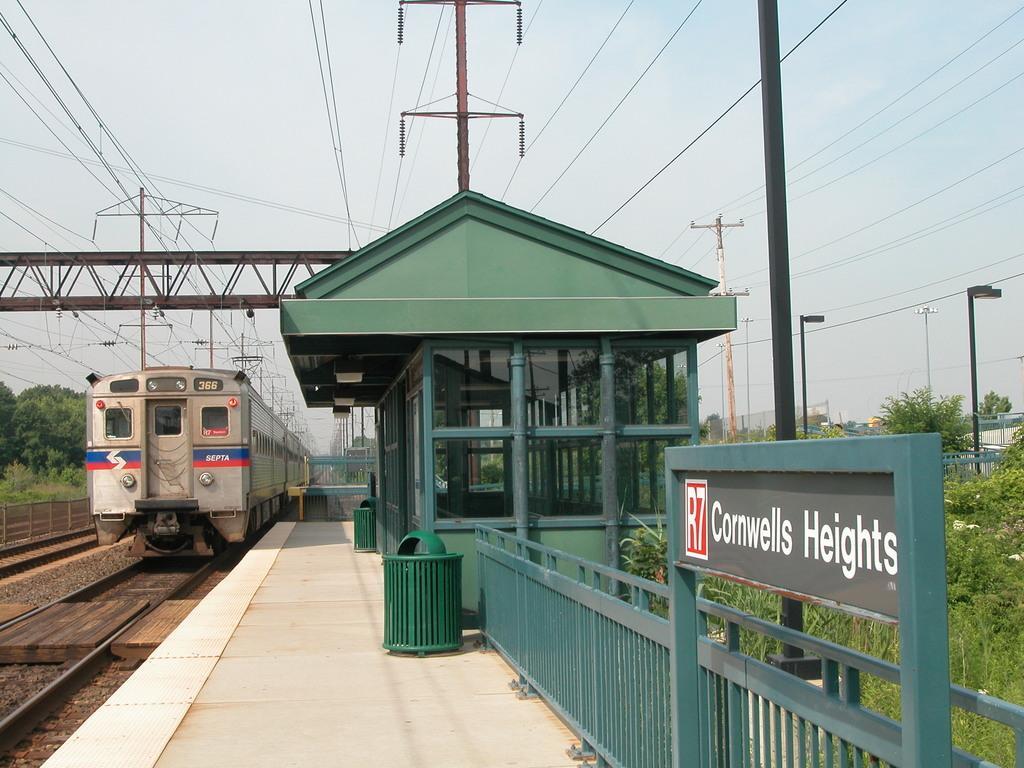Please provide a concise description of this image. There is a train on the track. Here we can see a shed, board, fence, bins, plants, poles, and trees. In the background there is sky. 